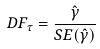Convert formula to latex. <formula><loc_0><loc_0><loc_500><loc_500>D F _ { \tau } = \frac { \hat { \gamma } } { S E ( \hat { \gamma } ) }</formula> 